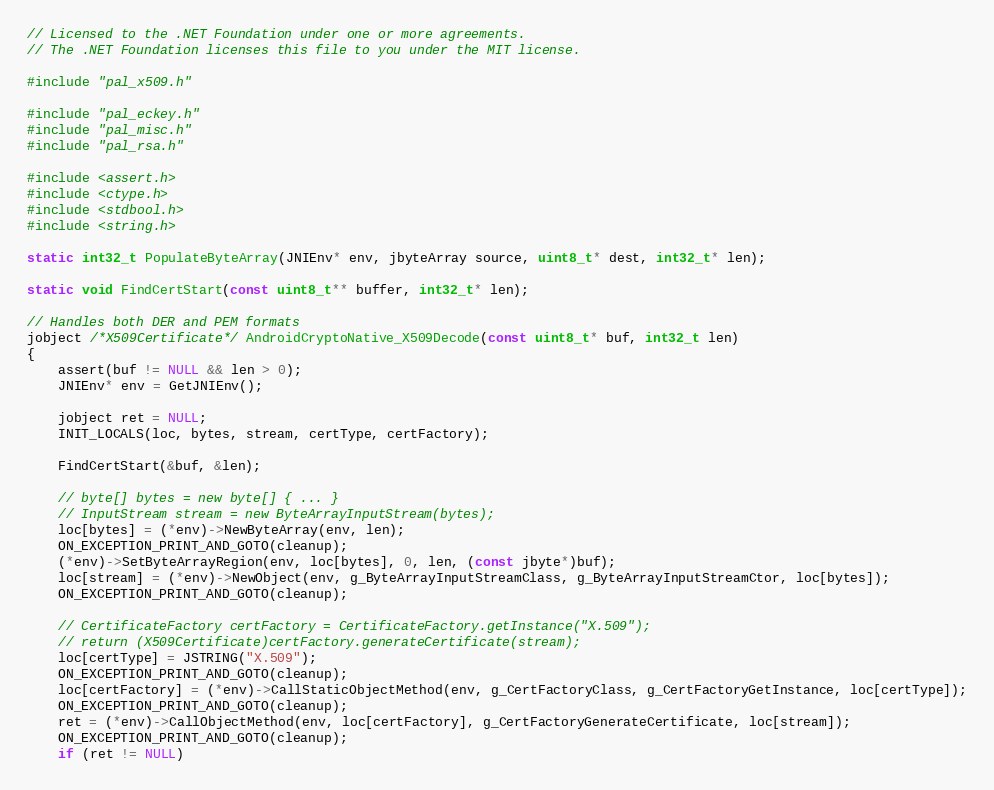<code> <loc_0><loc_0><loc_500><loc_500><_C_>// Licensed to the .NET Foundation under one or more agreements.
// The .NET Foundation licenses this file to you under the MIT license.

#include "pal_x509.h"

#include "pal_eckey.h"
#include "pal_misc.h"
#include "pal_rsa.h"

#include <assert.h>
#include <ctype.h>
#include <stdbool.h>
#include <string.h>

static int32_t PopulateByteArray(JNIEnv* env, jbyteArray source, uint8_t* dest, int32_t* len);

static void FindCertStart(const uint8_t** buffer, int32_t* len);

// Handles both DER and PEM formats
jobject /*X509Certificate*/ AndroidCryptoNative_X509Decode(const uint8_t* buf, int32_t len)
{
    assert(buf != NULL && len > 0);
    JNIEnv* env = GetJNIEnv();

    jobject ret = NULL;
    INIT_LOCALS(loc, bytes, stream, certType, certFactory);

    FindCertStart(&buf, &len);

    // byte[] bytes = new byte[] { ... }
    // InputStream stream = new ByteArrayInputStream(bytes);
    loc[bytes] = (*env)->NewByteArray(env, len);
    ON_EXCEPTION_PRINT_AND_GOTO(cleanup);
    (*env)->SetByteArrayRegion(env, loc[bytes], 0, len, (const jbyte*)buf);
    loc[stream] = (*env)->NewObject(env, g_ByteArrayInputStreamClass, g_ByteArrayInputStreamCtor, loc[bytes]);
    ON_EXCEPTION_PRINT_AND_GOTO(cleanup);

    // CertificateFactory certFactory = CertificateFactory.getInstance("X.509");
    // return (X509Certificate)certFactory.generateCertificate(stream);
    loc[certType] = JSTRING("X.509");
    ON_EXCEPTION_PRINT_AND_GOTO(cleanup);
    loc[certFactory] = (*env)->CallStaticObjectMethod(env, g_CertFactoryClass, g_CertFactoryGetInstance, loc[certType]);
    ON_EXCEPTION_PRINT_AND_GOTO(cleanup);
    ret = (*env)->CallObjectMethod(env, loc[certFactory], g_CertFactoryGenerateCertificate, loc[stream]);
    ON_EXCEPTION_PRINT_AND_GOTO(cleanup);
    if (ret != NULL)</code> 